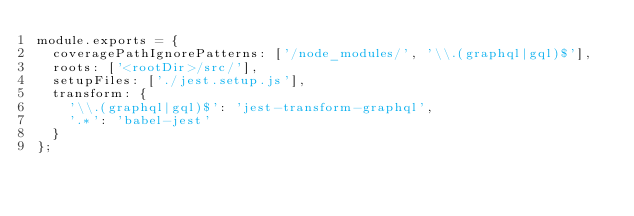<code> <loc_0><loc_0><loc_500><loc_500><_JavaScript_>module.exports = {
  coveragePathIgnorePatterns: ['/node_modules/', '\\.(graphql|gql)$'],
  roots: ['<rootDir>/src/'],
  setupFiles: ['./jest.setup.js'],
  transform: {
    '\\.(graphql|gql)$': 'jest-transform-graphql',
    '.*': 'babel-jest'
  }
};
</code> 